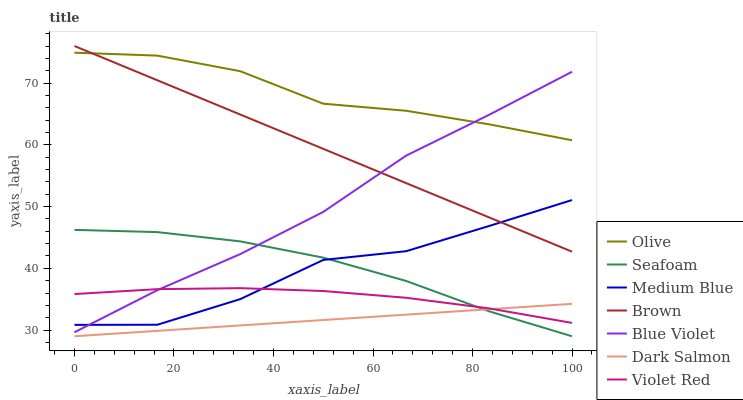Does Violet Red have the minimum area under the curve?
Answer yes or no. No. Does Violet Red have the maximum area under the curve?
Answer yes or no. No. Is Violet Red the smoothest?
Answer yes or no. No. Is Violet Red the roughest?
Answer yes or no. No. Does Violet Red have the lowest value?
Answer yes or no. No. Does Violet Red have the highest value?
Answer yes or no. No. Is Seafoam less than Olive?
Answer yes or no. Yes. Is Olive greater than Medium Blue?
Answer yes or no. Yes. Does Seafoam intersect Olive?
Answer yes or no. No. 